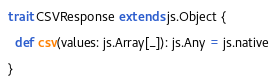<code> <loc_0><loc_0><loc_500><loc_500><_Scala_>trait CSVResponse extends js.Object {

  def csv(values: js.Array[_]): js.Any = js.native

}
</code> 